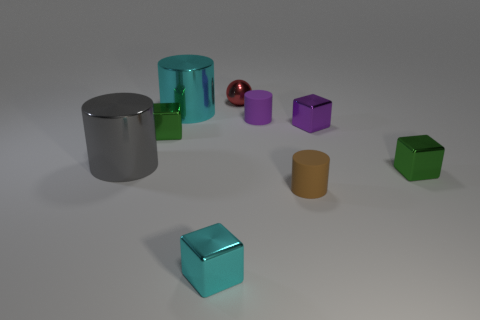What material is the small brown object to the right of the tiny purple cylinder?
Provide a succinct answer. Rubber. There is a matte object that is behind the small purple shiny cube; is its shape the same as the red thing left of the tiny purple matte cylinder?
Your answer should be very brief. No. Are there any cyan shiny blocks?
Keep it short and to the point. Yes. There is a purple thing that is the same shape as the large gray metal thing; what material is it?
Make the answer very short. Rubber. Are there any metallic cylinders in front of the gray metal cylinder?
Your answer should be compact. No. Is the material of the small green block on the right side of the cyan cube the same as the brown object?
Provide a succinct answer. No. Is there a small matte cylinder that has the same color as the metal ball?
Provide a succinct answer. No. The small brown matte thing is what shape?
Your response must be concise. Cylinder. The small metallic thing behind the small matte object to the left of the brown thing is what color?
Make the answer very short. Red. There is a green thing that is on the right side of the small red sphere; how big is it?
Your answer should be compact. Small. 